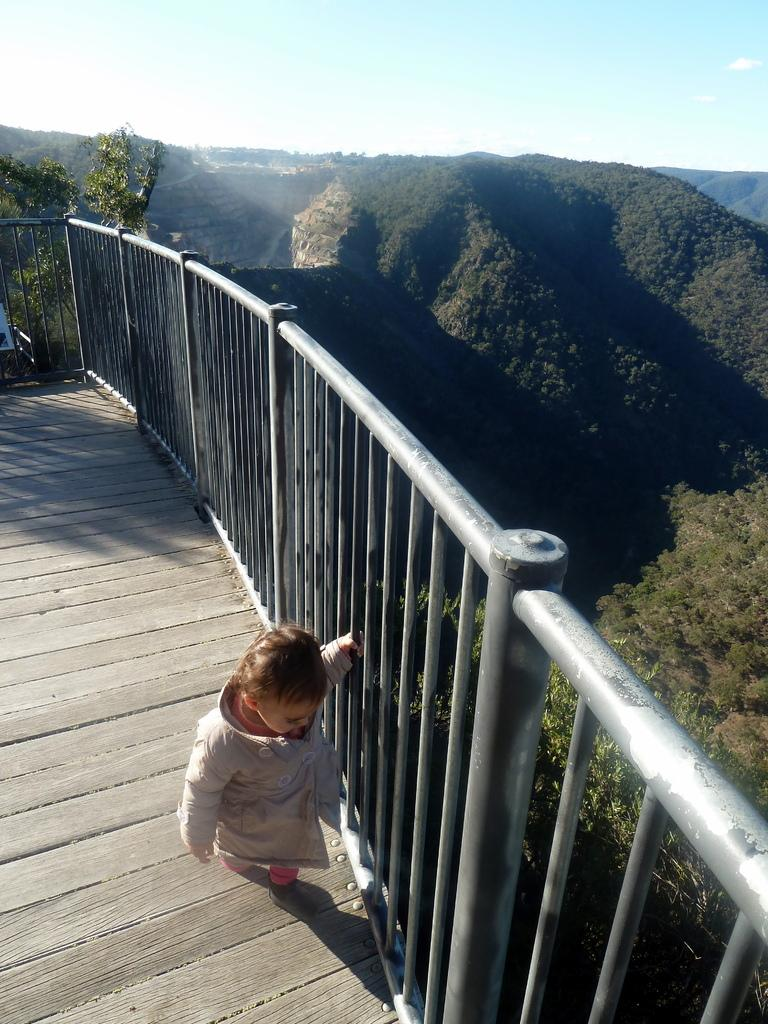What type of barrier can be seen in the image? There is a fence in the image. Where is the kid positioned in the image? The kid is standing on a wooden surface. What type of vegetation is present in the image? There are plants and trees in the image. What type of natural landform can be seen in the image? There are hills in the image. What is visible in the sky in the image? The sky is visible in the image, and clouds are present. What pets are visible in the image? There are no pets present in the image. What effect does the fence have on the existence of the trees in the image? The fence does not have any effect on the existence of the trees in the image; they are separate elements in the scene. 